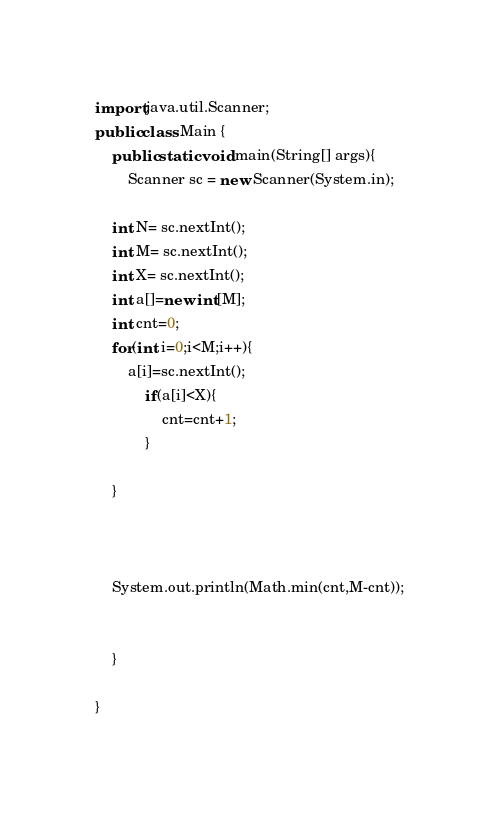Convert code to text. <code><loc_0><loc_0><loc_500><loc_500><_Java_>import java.util.Scanner;
public class Main {
	public static void main(String[] args){
		Scanner sc = new Scanner(System.in);

	int N= sc.nextInt();
	int M= sc.nextInt();
	int X= sc.nextInt();
	int a[]=new int[M];
    int cnt=0;
	for(int i=0;i<M;i++){
		a[i]=sc.nextInt();
	        if(a[i]<X){
	            cnt=cnt+1;
	        }
	    
	}

    

	System.out.println(Math.min(cnt,M-cnt));


	}

}
</code> 